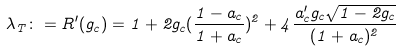Convert formula to latex. <formula><loc_0><loc_0><loc_500><loc_500>\lambda _ { T } \colon = R ^ { \prime } ( g _ { c } ) = 1 + 2 g _ { c } ( \frac { 1 - a _ { c } } { 1 + a _ { c } } ) ^ { 2 } + 4 \frac { a _ { c } ^ { \prime } g _ { c } \sqrt { 1 - 2 g _ { c } } } { ( 1 + a _ { c } ) ^ { 2 } }</formula> 